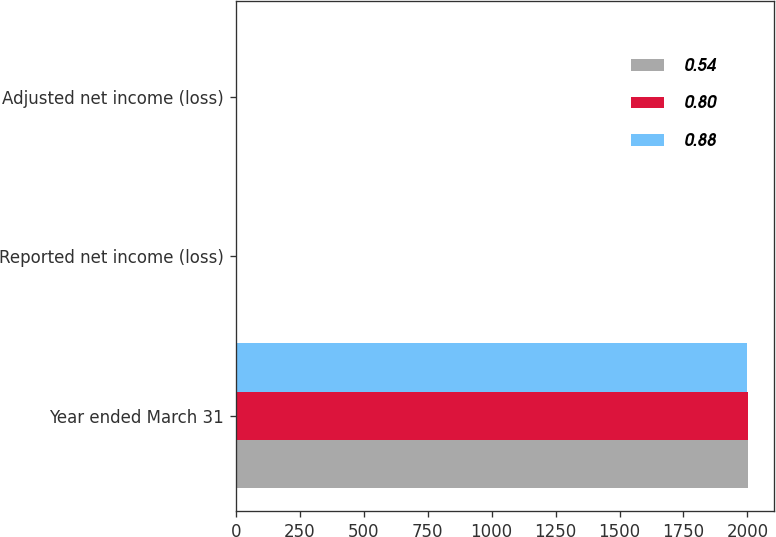<chart> <loc_0><loc_0><loc_500><loc_500><stacked_bar_chart><ecel><fcel>Year ended March 31<fcel>Reported net income (loss)<fcel>Adjusted net income (loss)<nl><fcel>0.54<fcel>2002<fcel>0.88<fcel>0.88<nl><fcel>0.8<fcel>2001<fcel>0.5<fcel>0.54<nl><fcel>0.88<fcel>2000<fcel>0.92<fcel>0.8<nl></chart> 